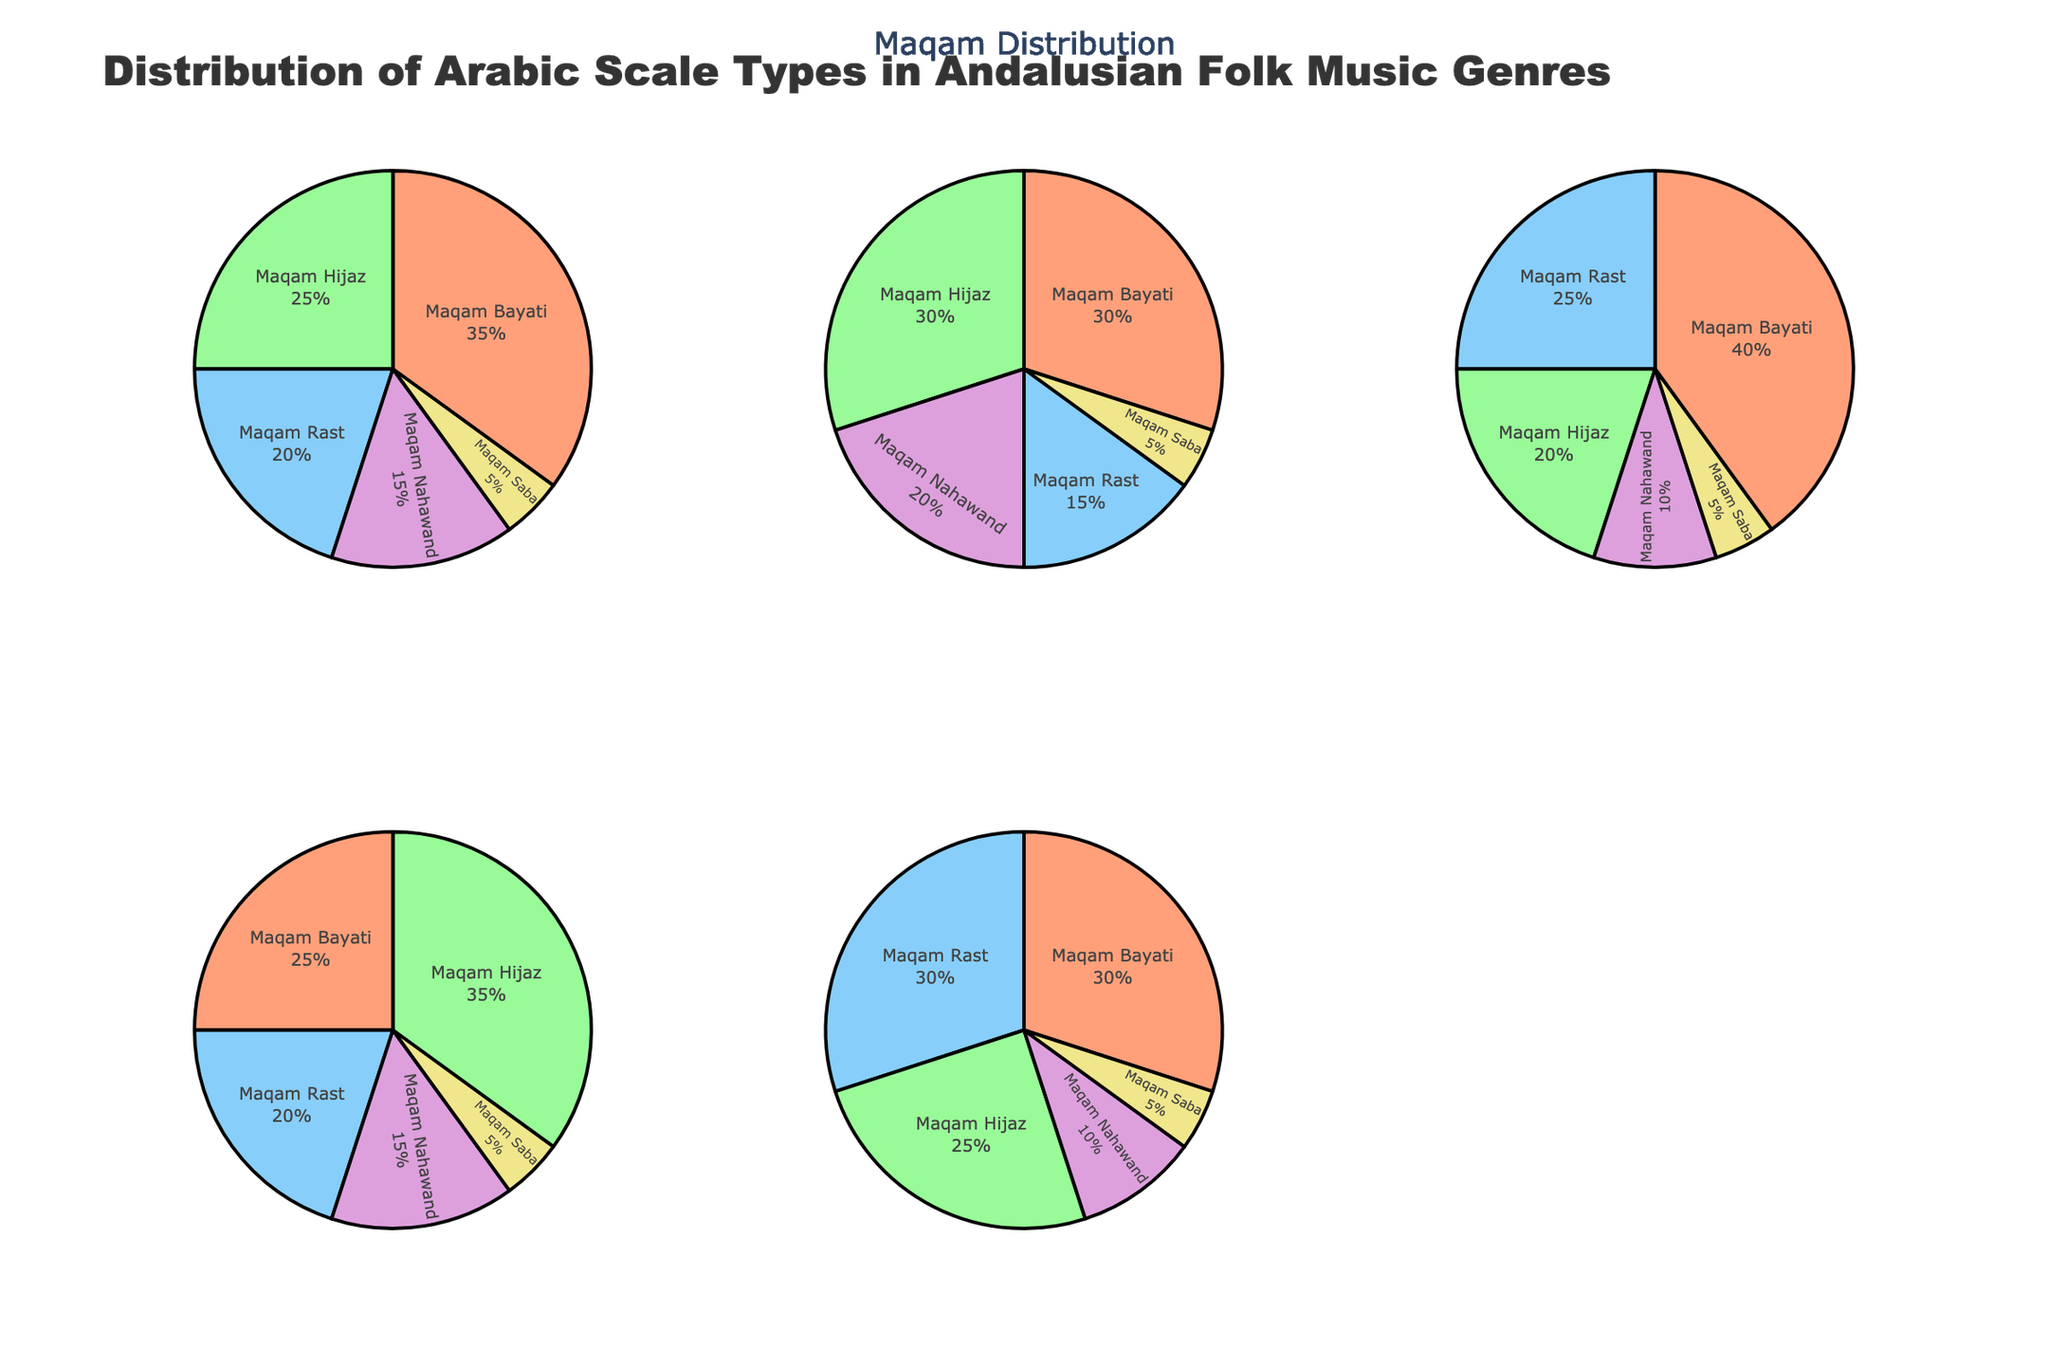What is the title of the plot? The title is usually displayed prominently at the top of the chart.
Answer: Distribution of Arabic Scale Types in Andalusian Folk Music Genres Which genre has the largest portion of Maqam Bayati? Look at the pie charts for each genre and compare the sizes of the Maqam Bayati sections.
Answer: Malagueña How many genres have an equal percentage of Maqam Saba? Examine the Maqam Saba slices across all genres to see if any are equal. All genres have Maqam Saba at 5%.
Answer: 5 In which genre is Maqam Hijaz most prevalent? Look for the largest Maqam Hijaz section among all the pies.
Answer: Bulerías What are the exact percentages of Maqam Nahawand found in Sevillanas and Bulerías combined? Sum the Maqam Nahawand percentages in both genres: Sevillanas (20%) + Bulerías (15%).
Answer: 35% Which two genres have the closest distribution of Maqam Rast? Compare the Maqam Rast slices in all the pie charts to find two that are most similar. Alegrías and Fandango both have 30% and 20% respectively.
Answer: Fandango and Alegrías What is the total percentage of Maqam Hijaz in Malagueña and Alegrías? Add the Maqam Hijaz percentages in Malagueña (20%) and Alegrías (25%).
Answer: 45% Which Maqam is least common across all genres? Identify the smallest slice in each pie chart, then find which Maqam consistently appears in small proportions. Maqam Saba is 5% in all genres.
Answer: Maqam Saba 